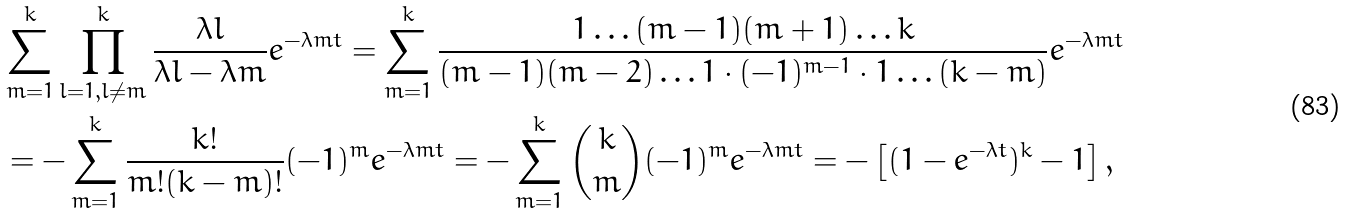<formula> <loc_0><loc_0><loc_500><loc_500>& \sum _ { m = 1 } ^ { k } \prod _ { l = 1 , l \neq m } ^ { k } \frac { \lambda l } { \lambda l - \lambda m } e ^ { - \lambda m t } = \sum _ { m = 1 } ^ { k } \frac { 1 \dots ( m - 1 ) ( m + 1 ) \dots k } { ( m - 1 ) ( m - 2 ) \dots 1 \cdot ( - 1 ) ^ { m - 1 } \cdot 1 \dots ( k - m ) } e ^ { - \lambda m t } \\ & = - \sum _ { m = 1 } ^ { k } \frac { k ! } { m ! ( k - m ) ! } ( - 1 ) ^ { m } e ^ { - \lambda m t } = - \sum _ { m = 1 } ^ { k } \binom { k } { m } ( - 1 ) ^ { m } e ^ { - \lambda m t } = - \left [ ( 1 - e ^ { - \lambda t } ) ^ { k } - 1 \right ] ,</formula> 